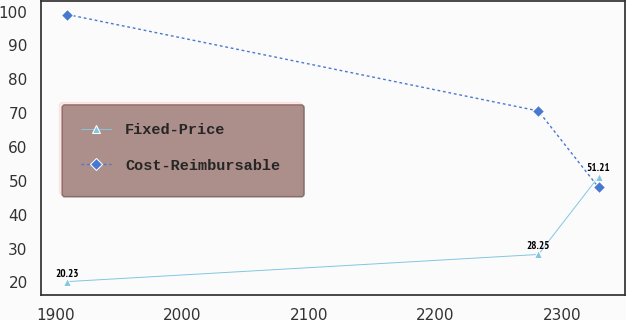<chart> <loc_0><loc_0><loc_500><loc_500><line_chart><ecel><fcel>Fixed-Price<fcel>Cost-Reimbursable<nl><fcel>1909.3<fcel>20.23<fcel>99.12<nl><fcel>2281.49<fcel>28.25<fcel>70.63<nl><fcel>2329.07<fcel>51.21<fcel>48.04<nl></chart> 